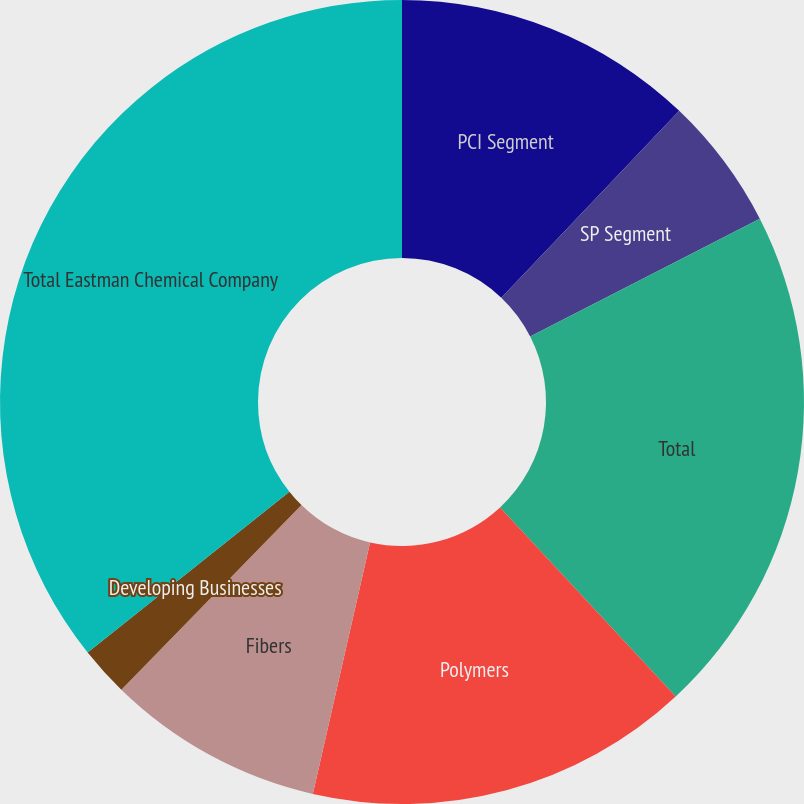Convert chart to OTSL. <chart><loc_0><loc_0><loc_500><loc_500><pie_chart><fcel>PCI Segment<fcel>SP Segment<fcel>Total<fcel>Polymers<fcel>Fibers<fcel>Developing Businesses<fcel>Total Eastman Chemical Company<nl><fcel>12.11%<fcel>5.36%<fcel>20.61%<fcel>15.48%<fcel>8.74%<fcel>1.99%<fcel>35.71%<nl></chart> 